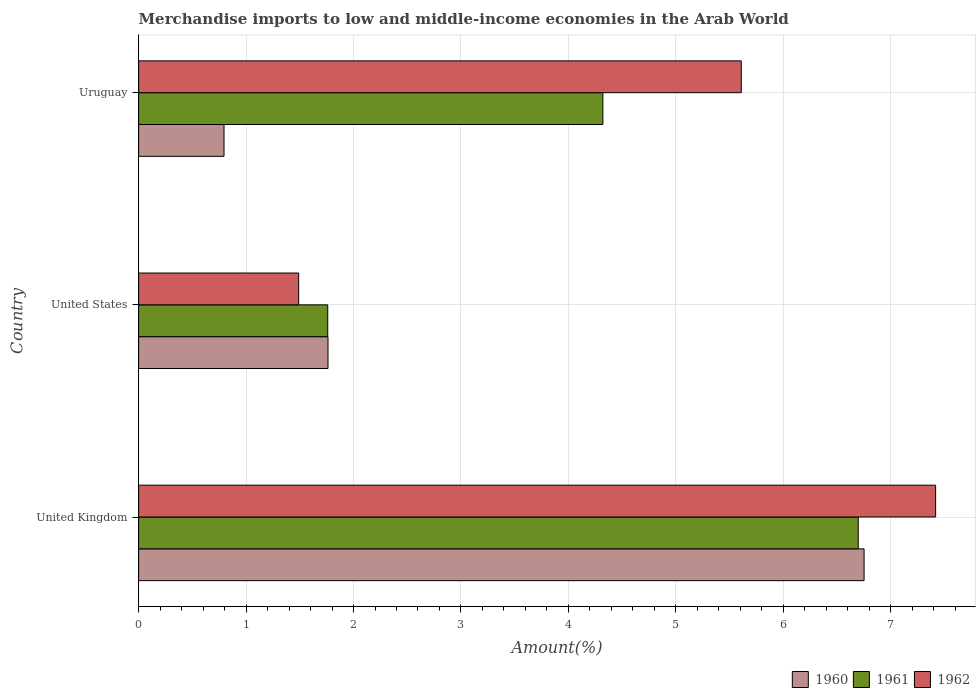How many groups of bars are there?
Provide a succinct answer. 3. How many bars are there on the 2nd tick from the top?
Make the answer very short. 3. How many bars are there on the 2nd tick from the bottom?
Provide a succinct answer. 3. In how many cases, is the number of bars for a given country not equal to the number of legend labels?
Your answer should be very brief. 0. What is the percentage of amount earned from merchandise imports in 1960 in United Kingdom?
Give a very brief answer. 6.75. Across all countries, what is the maximum percentage of amount earned from merchandise imports in 1962?
Offer a very short reply. 7.42. Across all countries, what is the minimum percentage of amount earned from merchandise imports in 1960?
Your answer should be very brief. 0.79. In which country was the percentage of amount earned from merchandise imports in 1960 minimum?
Give a very brief answer. Uruguay. What is the total percentage of amount earned from merchandise imports in 1962 in the graph?
Your response must be concise. 14.52. What is the difference between the percentage of amount earned from merchandise imports in 1962 in United Kingdom and that in United States?
Give a very brief answer. 5.93. What is the difference between the percentage of amount earned from merchandise imports in 1961 in United Kingdom and the percentage of amount earned from merchandise imports in 1962 in Uruguay?
Provide a short and direct response. 1.09. What is the average percentage of amount earned from merchandise imports in 1960 per country?
Make the answer very short. 3.1. What is the difference between the percentage of amount earned from merchandise imports in 1960 and percentage of amount earned from merchandise imports in 1962 in United States?
Make the answer very short. 0.27. In how many countries, is the percentage of amount earned from merchandise imports in 1961 greater than 5.6 %?
Provide a succinct answer. 1. What is the ratio of the percentage of amount earned from merchandise imports in 1960 in United States to that in Uruguay?
Offer a very short reply. 2.22. Is the percentage of amount earned from merchandise imports in 1960 in United Kingdom less than that in United States?
Your response must be concise. No. Is the difference between the percentage of amount earned from merchandise imports in 1960 in United Kingdom and Uruguay greater than the difference between the percentage of amount earned from merchandise imports in 1962 in United Kingdom and Uruguay?
Your answer should be compact. Yes. What is the difference between the highest and the second highest percentage of amount earned from merchandise imports in 1961?
Your answer should be compact. 2.38. What is the difference between the highest and the lowest percentage of amount earned from merchandise imports in 1960?
Provide a succinct answer. 5.96. Is the sum of the percentage of amount earned from merchandise imports in 1960 in United States and Uruguay greater than the maximum percentage of amount earned from merchandise imports in 1962 across all countries?
Offer a very short reply. No. What does the 1st bar from the top in Uruguay represents?
Keep it short and to the point. 1962. What does the 3rd bar from the bottom in Uruguay represents?
Your answer should be compact. 1962. What is the difference between two consecutive major ticks on the X-axis?
Provide a short and direct response. 1. Are the values on the major ticks of X-axis written in scientific E-notation?
Provide a succinct answer. No. Does the graph contain any zero values?
Offer a terse response. No. Does the graph contain grids?
Keep it short and to the point. Yes. How are the legend labels stacked?
Make the answer very short. Horizontal. What is the title of the graph?
Your answer should be compact. Merchandise imports to low and middle-income economies in the Arab World. What is the label or title of the X-axis?
Give a very brief answer. Amount(%). What is the Amount(%) of 1960 in United Kingdom?
Your answer should be compact. 6.75. What is the Amount(%) in 1961 in United Kingdom?
Offer a terse response. 6.7. What is the Amount(%) in 1962 in United Kingdom?
Offer a very short reply. 7.42. What is the Amount(%) of 1960 in United States?
Keep it short and to the point. 1.76. What is the Amount(%) of 1961 in United States?
Keep it short and to the point. 1.76. What is the Amount(%) of 1962 in United States?
Provide a short and direct response. 1.49. What is the Amount(%) in 1960 in Uruguay?
Ensure brevity in your answer.  0.79. What is the Amount(%) in 1961 in Uruguay?
Your answer should be compact. 4.32. What is the Amount(%) in 1962 in Uruguay?
Keep it short and to the point. 5.61. Across all countries, what is the maximum Amount(%) of 1960?
Offer a terse response. 6.75. Across all countries, what is the maximum Amount(%) in 1961?
Your response must be concise. 6.7. Across all countries, what is the maximum Amount(%) of 1962?
Your answer should be compact. 7.42. Across all countries, what is the minimum Amount(%) of 1960?
Your response must be concise. 0.79. Across all countries, what is the minimum Amount(%) in 1961?
Provide a short and direct response. 1.76. Across all countries, what is the minimum Amount(%) in 1962?
Your response must be concise. 1.49. What is the total Amount(%) in 1960 in the graph?
Make the answer very short. 9.31. What is the total Amount(%) in 1961 in the graph?
Offer a terse response. 12.78. What is the total Amount(%) in 1962 in the graph?
Keep it short and to the point. 14.52. What is the difference between the Amount(%) in 1960 in United Kingdom and that in United States?
Ensure brevity in your answer.  4.99. What is the difference between the Amount(%) in 1961 in United Kingdom and that in United States?
Ensure brevity in your answer.  4.94. What is the difference between the Amount(%) in 1962 in United Kingdom and that in United States?
Keep it short and to the point. 5.93. What is the difference between the Amount(%) in 1960 in United Kingdom and that in Uruguay?
Offer a very short reply. 5.96. What is the difference between the Amount(%) in 1961 in United Kingdom and that in Uruguay?
Give a very brief answer. 2.38. What is the difference between the Amount(%) of 1962 in United Kingdom and that in Uruguay?
Keep it short and to the point. 1.81. What is the difference between the Amount(%) of 1960 in United States and that in Uruguay?
Offer a terse response. 0.97. What is the difference between the Amount(%) in 1961 in United States and that in Uruguay?
Provide a succinct answer. -2.56. What is the difference between the Amount(%) of 1962 in United States and that in Uruguay?
Offer a terse response. -4.12. What is the difference between the Amount(%) of 1960 in United Kingdom and the Amount(%) of 1961 in United States?
Make the answer very short. 4.99. What is the difference between the Amount(%) of 1960 in United Kingdom and the Amount(%) of 1962 in United States?
Provide a short and direct response. 5.26. What is the difference between the Amount(%) of 1961 in United Kingdom and the Amount(%) of 1962 in United States?
Your answer should be very brief. 5.21. What is the difference between the Amount(%) of 1960 in United Kingdom and the Amount(%) of 1961 in Uruguay?
Make the answer very short. 2.43. What is the difference between the Amount(%) of 1960 in United Kingdom and the Amount(%) of 1962 in Uruguay?
Offer a very short reply. 1.14. What is the difference between the Amount(%) of 1961 in United Kingdom and the Amount(%) of 1962 in Uruguay?
Provide a short and direct response. 1.09. What is the difference between the Amount(%) in 1960 in United States and the Amount(%) in 1961 in Uruguay?
Keep it short and to the point. -2.56. What is the difference between the Amount(%) in 1960 in United States and the Amount(%) in 1962 in Uruguay?
Your answer should be compact. -3.85. What is the difference between the Amount(%) in 1961 in United States and the Amount(%) in 1962 in Uruguay?
Your response must be concise. -3.85. What is the average Amount(%) in 1960 per country?
Give a very brief answer. 3.1. What is the average Amount(%) of 1961 per country?
Make the answer very short. 4.26. What is the average Amount(%) of 1962 per country?
Provide a short and direct response. 4.84. What is the difference between the Amount(%) in 1960 and Amount(%) in 1961 in United Kingdom?
Your answer should be very brief. 0.05. What is the difference between the Amount(%) of 1960 and Amount(%) of 1962 in United Kingdom?
Your answer should be very brief. -0.67. What is the difference between the Amount(%) of 1961 and Amount(%) of 1962 in United Kingdom?
Offer a very short reply. -0.72. What is the difference between the Amount(%) in 1960 and Amount(%) in 1961 in United States?
Offer a very short reply. 0. What is the difference between the Amount(%) of 1960 and Amount(%) of 1962 in United States?
Provide a succinct answer. 0.27. What is the difference between the Amount(%) in 1961 and Amount(%) in 1962 in United States?
Your answer should be compact. 0.27. What is the difference between the Amount(%) of 1960 and Amount(%) of 1961 in Uruguay?
Ensure brevity in your answer.  -3.53. What is the difference between the Amount(%) in 1960 and Amount(%) in 1962 in Uruguay?
Keep it short and to the point. -4.81. What is the difference between the Amount(%) in 1961 and Amount(%) in 1962 in Uruguay?
Give a very brief answer. -1.29. What is the ratio of the Amount(%) of 1960 in United Kingdom to that in United States?
Your response must be concise. 3.83. What is the ratio of the Amount(%) of 1961 in United Kingdom to that in United States?
Ensure brevity in your answer.  3.81. What is the ratio of the Amount(%) in 1962 in United Kingdom to that in United States?
Offer a very short reply. 4.98. What is the ratio of the Amount(%) of 1960 in United Kingdom to that in Uruguay?
Provide a short and direct response. 8.5. What is the ratio of the Amount(%) of 1961 in United Kingdom to that in Uruguay?
Keep it short and to the point. 1.55. What is the ratio of the Amount(%) of 1962 in United Kingdom to that in Uruguay?
Provide a succinct answer. 1.32. What is the ratio of the Amount(%) in 1960 in United States to that in Uruguay?
Offer a terse response. 2.22. What is the ratio of the Amount(%) of 1961 in United States to that in Uruguay?
Keep it short and to the point. 0.41. What is the ratio of the Amount(%) of 1962 in United States to that in Uruguay?
Offer a terse response. 0.27. What is the difference between the highest and the second highest Amount(%) in 1960?
Provide a short and direct response. 4.99. What is the difference between the highest and the second highest Amount(%) of 1961?
Your answer should be compact. 2.38. What is the difference between the highest and the second highest Amount(%) in 1962?
Offer a terse response. 1.81. What is the difference between the highest and the lowest Amount(%) in 1960?
Offer a very short reply. 5.96. What is the difference between the highest and the lowest Amount(%) in 1961?
Your answer should be compact. 4.94. What is the difference between the highest and the lowest Amount(%) in 1962?
Your answer should be compact. 5.93. 